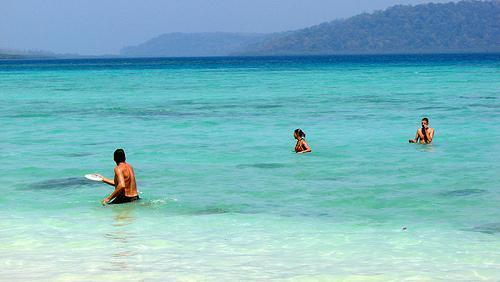How many people are in the water?
Give a very brief answer. 3. How many women are there?
Give a very brief answer. 1. How many men are there?
Give a very brief answer. 2. How many horses are there?
Give a very brief answer. 0. 